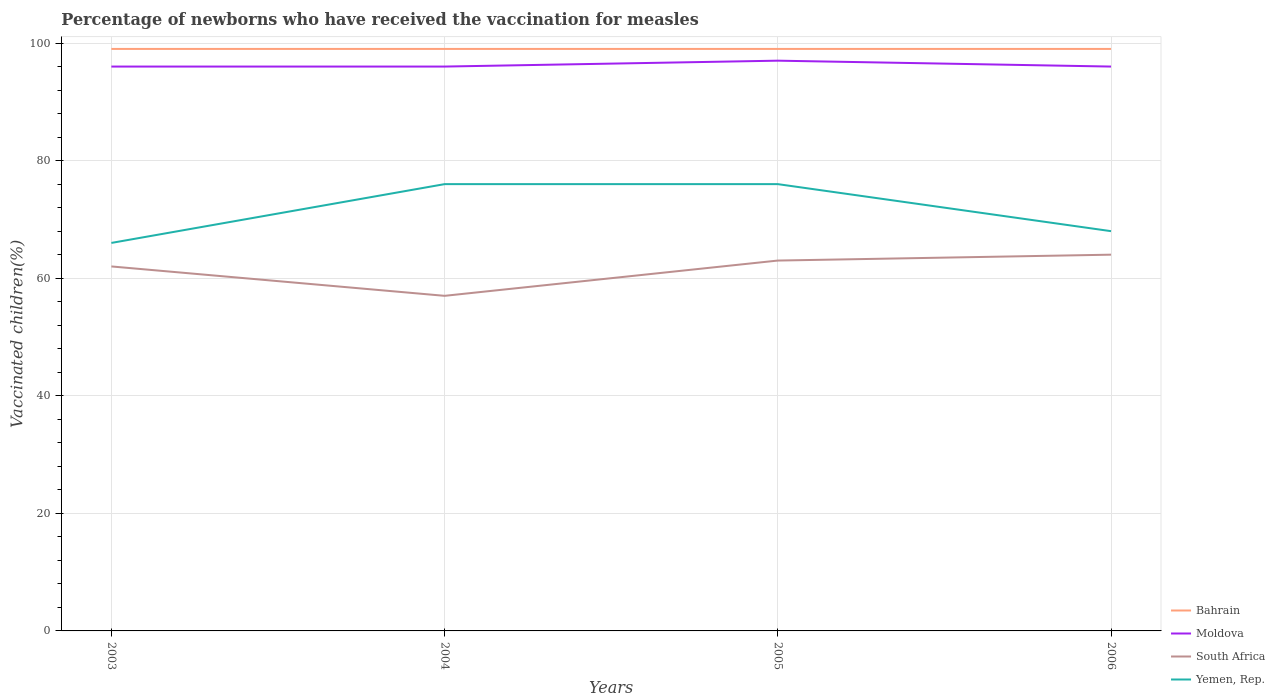How many different coloured lines are there?
Provide a succinct answer. 4. Does the line corresponding to Bahrain intersect with the line corresponding to South Africa?
Offer a terse response. No. Is the number of lines equal to the number of legend labels?
Your answer should be very brief. Yes. Across all years, what is the maximum percentage of vaccinated children in Yemen, Rep.?
Offer a very short reply. 66. In which year was the percentage of vaccinated children in South Africa maximum?
Provide a short and direct response. 2004. What is the total percentage of vaccinated children in South Africa in the graph?
Make the answer very short. 5. Is the percentage of vaccinated children in Moldova strictly greater than the percentage of vaccinated children in Bahrain over the years?
Your answer should be very brief. Yes. How many lines are there?
Your answer should be very brief. 4. How many years are there in the graph?
Make the answer very short. 4. Are the values on the major ticks of Y-axis written in scientific E-notation?
Provide a short and direct response. No. Does the graph contain grids?
Provide a short and direct response. Yes. How are the legend labels stacked?
Your answer should be compact. Vertical. What is the title of the graph?
Give a very brief answer. Percentage of newborns who have received the vaccination for measles. Does "Monaco" appear as one of the legend labels in the graph?
Provide a succinct answer. No. What is the label or title of the X-axis?
Your response must be concise. Years. What is the label or title of the Y-axis?
Give a very brief answer. Vaccinated children(%). What is the Vaccinated children(%) in Bahrain in 2003?
Give a very brief answer. 99. What is the Vaccinated children(%) of Moldova in 2003?
Offer a terse response. 96. What is the Vaccinated children(%) in Bahrain in 2004?
Your answer should be compact. 99. What is the Vaccinated children(%) of Moldova in 2004?
Keep it short and to the point. 96. What is the Vaccinated children(%) of Bahrain in 2005?
Give a very brief answer. 99. What is the Vaccinated children(%) of Moldova in 2005?
Your answer should be very brief. 97. What is the Vaccinated children(%) in Bahrain in 2006?
Keep it short and to the point. 99. What is the Vaccinated children(%) in Moldova in 2006?
Your answer should be compact. 96. What is the Vaccinated children(%) in South Africa in 2006?
Make the answer very short. 64. Across all years, what is the maximum Vaccinated children(%) of Bahrain?
Provide a short and direct response. 99. Across all years, what is the maximum Vaccinated children(%) of Moldova?
Your answer should be compact. 97. Across all years, what is the maximum Vaccinated children(%) of South Africa?
Offer a terse response. 64. Across all years, what is the minimum Vaccinated children(%) of Moldova?
Your answer should be very brief. 96. Across all years, what is the minimum Vaccinated children(%) in South Africa?
Your answer should be compact. 57. What is the total Vaccinated children(%) in Bahrain in the graph?
Ensure brevity in your answer.  396. What is the total Vaccinated children(%) in Moldova in the graph?
Offer a terse response. 385. What is the total Vaccinated children(%) in South Africa in the graph?
Give a very brief answer. 246. What is the total Vaccinated children(%) of Yemen, Rep. in the graph?
Your answer should be compact. 286. What is the difference between the Vaccinated children(%) in Bahrain in 2003 and that in 2004?
Offer a very short reply. 0. What is the difference between the Vaccinated children(%) in Yemen, Rep. in 2003 and that in 2004?
Your response must be concise. -10. What is the difference between the Vaccinated children(%) in Bahrain in 2003 and that in 2005?
Your response must be concise. 0. What is the difference between the Vaccinated children(%) of Moldova in 2003 and that in 2005?
Your answer should be very brief. -1. What is the difference between the Vaccinated children(%) in South Africa in 2003 and that in 2005?
Make the answer very short. -1. What is the difference between the Vaccinated children(%) of Bahrain in 2003 and that in 2006?
Make the answer very short. 0. What is the difference between the Vaccinated children(%) in Moldova in 2003 and that in 2006?
Provide a short and direct response. 0. What is the difference between the Vaccinated children(%) in South Africa in 2003 and that in 2006?
Your answer should be compact. -2. What is the difference between the Vaccinated children(%) of Bahrain in 2004 and that in 2005?
Offer a terse response. 0. What is the difference between the Vaccinated children(%) of South Africa in 2004 and that in 2005?
Offer a terse response. -6. What is the difference between the Vaccinated children(%) of Moldova in 2004 and that in 2006?
Offer a very short reply. 0. What is the difference between the Vaccinated children(%) in South Africa in 2004 and that in 2006?
Provide a short and direct response. -7. What is the difference between the Vaccinated children(%) in Yemen, Rep. in 2005 and that in 2006?
Your response must be concise. 8. What is the difference between the Vaccinated children(%) in Bahrain in 2003 and the Vaccinated children(%) in South Africa in 2004?
Give a very brief answer. 42. What is the difference between the Vaccinated children(%) in Bahrain in 2003 and the Vaccinated children(%) in Yemen, Rep. in 2004?
Your response must be concise. 23. What is the difference between the Vaccinated children(%) of Moldova in 2003 and the Vaccinated children(%) of Yemen, Rep. in 2004?
Your answer should be compact. 20. What is the difference between the Vaccinated children(%) in Bahrain in 2003 and the Vaccinated children(%) in Moldova in 2005?
Your answer should be very brief. 2. What is the difference between the Vaccinated children(%) of Bahrain in 2003 and the Vaccinated children(%) of South Africa in 2005?
Keep it short and to the point. 36. What is the difference between the Vaccinated children(%) in Moldova in 2003 and the Vaccinated children(%) in Yemen, Rep. in 2005?
Ensure brevity in your answer.  20. What is the difference between the Vaccinated children(%) in Bahrain in 2003 and the Vaccinated children(%) in Moldova in 2006?
Provide a short and direct response. 3. What is the difference between the Vaccinated children(%) of Moldova in 2004 and the Vaccinated children(%) of Yemen, Rep. in 2005?
Provide a short and direct response. 20. What is the difference between the Vaccinated children(%) of South Africa in 2004 and the Vaccinated children(%) of Yemen, Rep. in 2005?
Keep it short and to the point. -19. What is the difference between the Vaccinated children(%) of South Africa in 2004 and the Vaccinated children(%) of Yemen, Rep. in 2006?
Make the answer very short. -11. What is the difference between the Vaccinated children(%) of Bahrain in 2005 and the Vaccinated children(%) of South Africa in 2006?
Make the answer very short. 35. What is the difference between the Vaccinated children(%) of Bahrain in 2005 and the Vaccinated children(%) of Yemen, Rep. in 2006?
Make the answer very short. 31. What is the difference between the Vaccinated children(%) of South Africa in 2005 and the Vaccinated children(%) of Yemen, Rep. in 2006?
Give a very brief answer. -5. What is the average Vaccinated children(%) in Moldova per year?
Offer a very short reply. 96.25. What is the average Vaccinated children(%) in South Africa per year?
Make the answer very short. 61.5. What is the average Vaccinated children(%) of Yemen, Rep. per year?
Provide a short and direct response. 71.5. In the year 2003, what is the difference between the Vaccinated children(%) of Bahrain and Vaccinated children(%) of South Africa?
Make the answer very short. 37. In the year 2003, what is the difference between the Vaccinated children(%) of Moldova and Vaccinated children(%) of Yemen, Rep.?
Offer a very short reply. 30. In the year 2004, what is the difference between the Vaccinated children(%) in Bahrain and Vaccinated children(%) in South Africa?
Offer a very short reply. 42. In the year 2004, what is the difference between the Vaccinated children(%) in Bahrain and Vaccinated children(%) in Yemen, Rep.?
Ensure brevity in your answer.  23. In the year 2004, what is the difference between the Vaccinated children(%) of South Africa and Vaccinated children(%) of Yemen, Rep.?
Provide a succinct answer. -19. In the year 2005, what is the difference between the Vaccinated children(%) of Bahrain and Vaccinated children(%) of South Africa?
Ensure brevity in your answer.  36. In the year 2005, what is the difference between the Vaccinated children(%) of Moldova and Vaccinated children(%) of South Africa?
Your answer should be compact. 34. In the year 2005, what is the difference between the Vaccinated children(%) in Moldova and Vaccinated children(%) in Yemen, Rep.?
Provide a succinct answer. 21. In the year 2005, what is the difference between the Vaccinated children(%) of South Africa and Vaccinated children(%) of Yemen, Rep.?
Offer a very short reply. -13. In the year 2006, what is the difference between the Vaccinated children(%) of Bahrain and Vaccinated children(%) of South Africa?
Offer a terse response. 35. In the year 2006, what is the difference between the Vaccinated children(%) in Moldova and Vaccinated children(%) in South Africa?
Your answer should be compact. 32. In the year 2006, what is the difference between the Vaccinated children(%) of Moldova and Vaccinated children(%) of Yemen, Rep.?
Provide a short and direct response. 28. In the year 2006, what is the difference between the Vaccinated children(%) of South Africa and Vaccinated children(%) of Yemen, Rep.?
Offer a very short reply. -4. What is the ratio of the Vaccinated children(%) of Bahrain in 2003 to that in 2004?
Your answer should be compact. 1. What is the ratio of the Vaccinated children(%) of South Africa in 2003 to that in 2004?
Keep it short and to the point. 1.09. What is the ratio of the Vaccinated children(%) of Yemen, Rep. in 2003 to that in 2004?
Offer a terse response. 0.87. What is the ratio of the Vaccinated children(%) of Moldova in 2003 to that in 2005?
Offer a terse response. 0.99. What is the ratio of the Vaccinated children(%) in South Africa in 2003 to that in 2005?
Your response must be concise. 0.98. What is the ratio of the Vaccinated children(%) of Yemen, Rep. in 2003 to that in 2005?
Ensure brevity in your answer.  0.87. What is the ratio of the Vaccinated children(%) of Bahrain in 2003 to that in 2006?
Your response must be concise. 1. What is the ratio of the Vaccinated children(%) in South Africa in 2003 to that in 2006?
Your answer should be very brief. 0.97. What is the ratio of the Vaccinated children(%) in Yemen, Rep. in 2003 to that in 2006?
Your response must be concise. 0.97. What is the ratio of the Vaccinated children(%) of South Africa in 2004 to that in 2005?
Keep it short and to the point. 0.9. What is the ratio of the Vaccinated children(%) of Yemen, Rep. in 2004 to that in 2005?
Give a very brief answer. 1. What is the ratio of the Vaccinated children(%) of Moldova in 2004 to that in 2006?
Your answer should be compact. 1. What is the ratio of the Vaccinated children(%) of South Africa in 2004 to that in 2006?
Your answer should be very brief. 0.89. What is the ratio of the Vaccinated children(%) of Yemen, Rep. in 2004 to that in 2006?
Offer a terse response. 1.12. What is the ratio of the Vaccinated children(%) of Bahrain in 2005 to that in 2006?
Offer a terse response. 1. What is the ratio of the Vaccinated children(%) of Moldova in 2005 to that in 2006?
Ensure brevity in your answer.  1.01. What is the ratio of the Vaccinated children(%) of South Africa in 2005 to that in 2006?
Provide a short and direct response. 0.98. What is the ratio of the Vaccinated children(%) of Yemen, Rep. in 2005 to that in 2006?
Your answer should be very brief. 1.12. What is the difference between the highest and the second highest Vaccinated children(%) in Bahrain?
Your response must be concise. 0. 